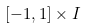Convert formula to latex. <formula><loc_0><loc_0><loc_500><loc_500>[ - 1 , 1 ] \times I</formula> 